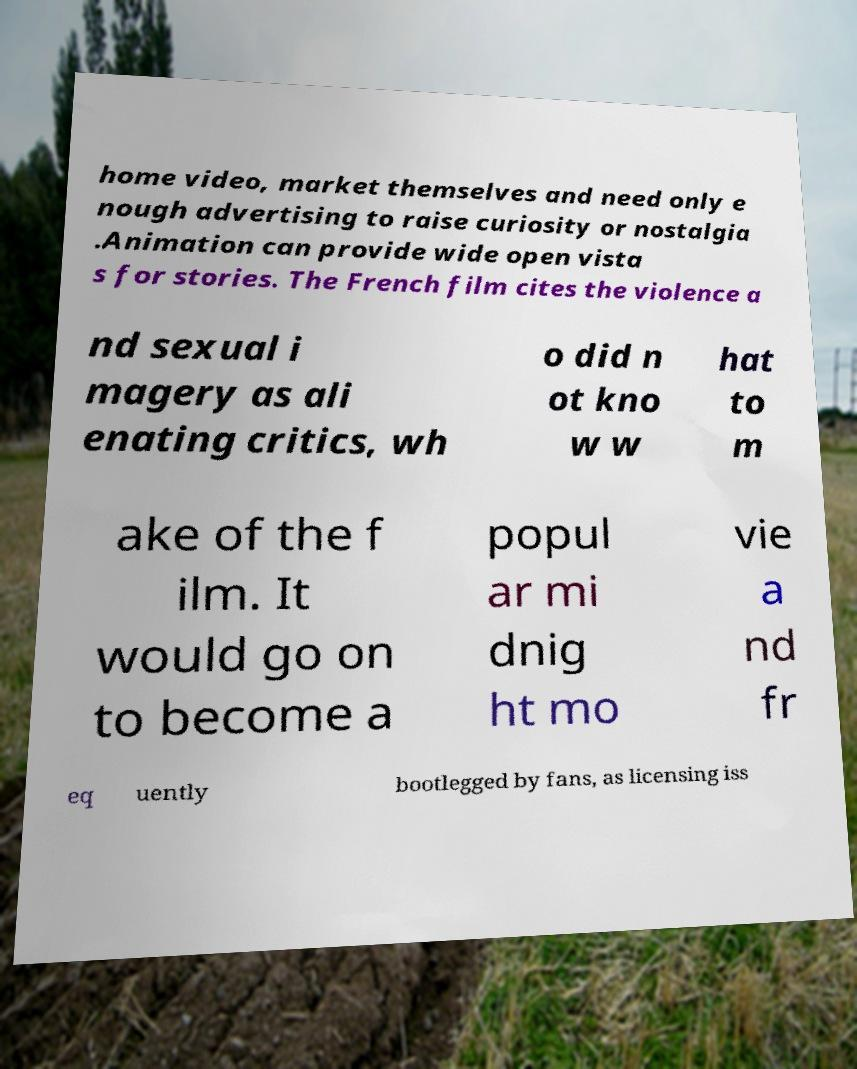Could you assist in decoding the text presented in this image and type it out clearly? home video, market themselves and need only e nough advertising to raise curiosity or nostalgia .Animation can provide wide open vista s for stories. The French film cites the violence a nd sexual i magery as ali enating critics, wh o did n ot kno w w hat to m ake of the f ilm. It would go on to become a popul ar mi dnig ht mo vie a nd fr eq uently bootlegged by fans, as licensing iss 